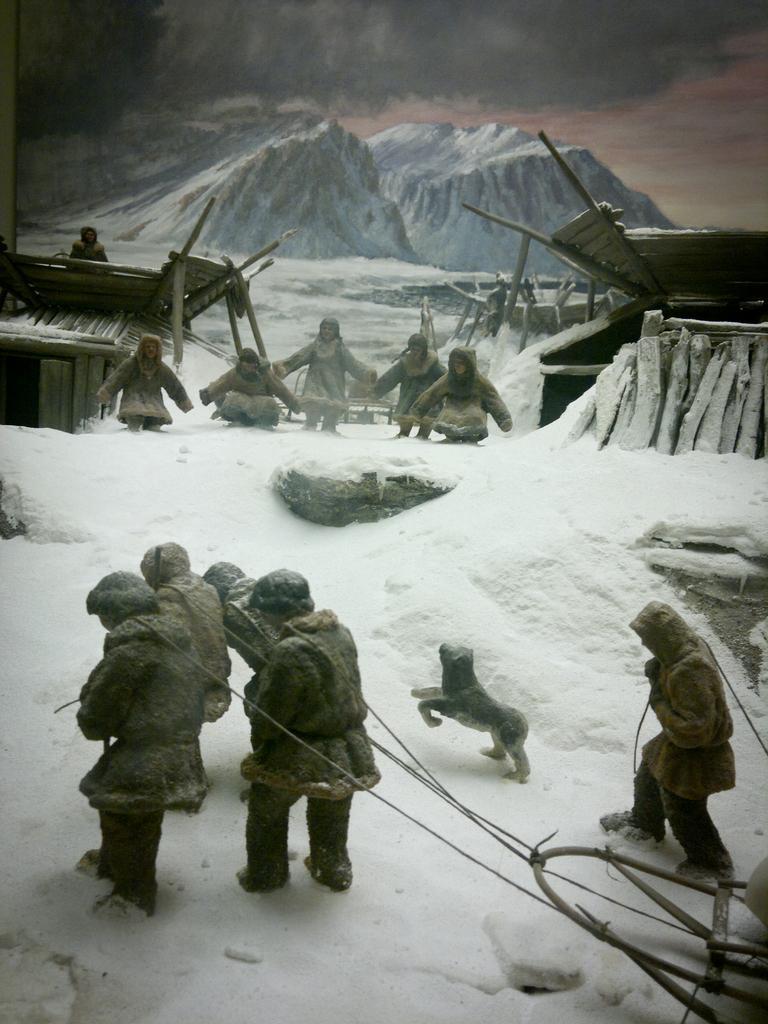Please provide a concise description of this image. In this picture there is snow land in the foreground area, where we can see people holding ropes in their hands, a dog, children and bamboo houses in the area and there are mountains and sky in the background area, it seems like an animated image. 